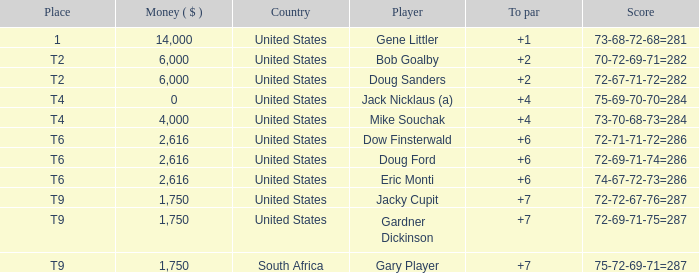What is the highest To Par, when Place is "1"? 1.0. 